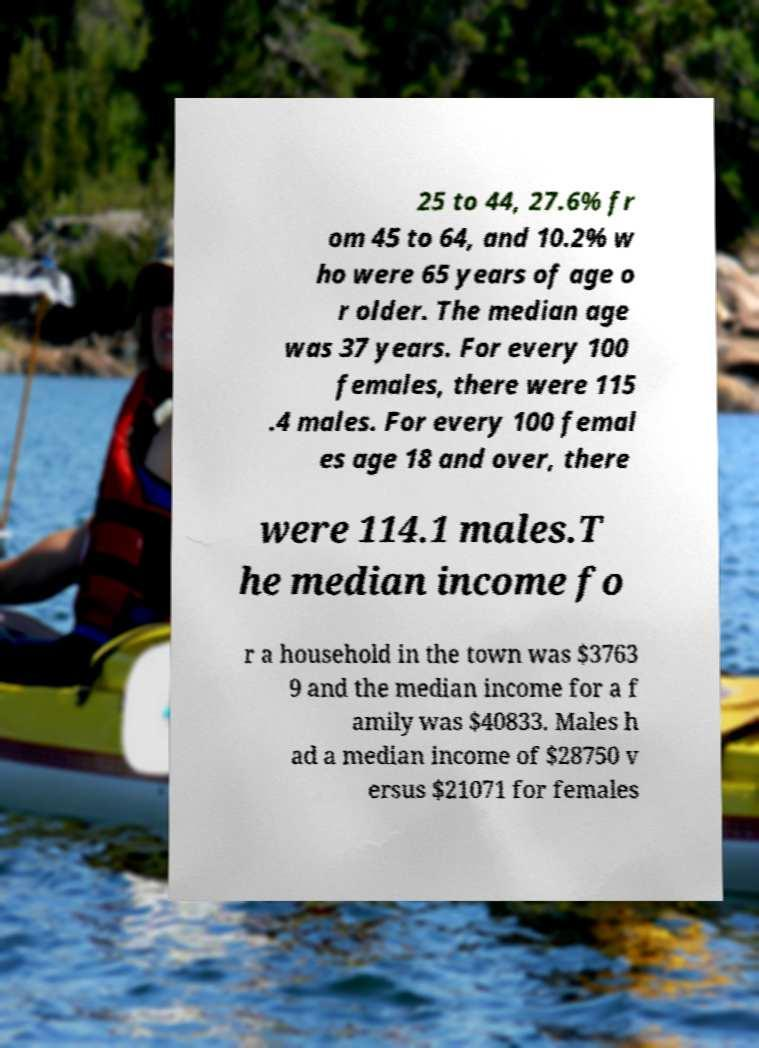There's text embedded in this image that I need extracted. Can you transcribe it verbatim? 25 to 44, 27.6% fr om 45 to 64, and 10.2% w ho were 65 years of age o r older. The median age was 37 years. For every 100 females, there were 115 .4 males. For every 100 femal es age 18 and over, there were 114.1 males.T he median income fo r a household in the town was $3763 9 and the median income for a f amily was $40833. Males h ad a median income of $28750 v ersus $21071 for females 